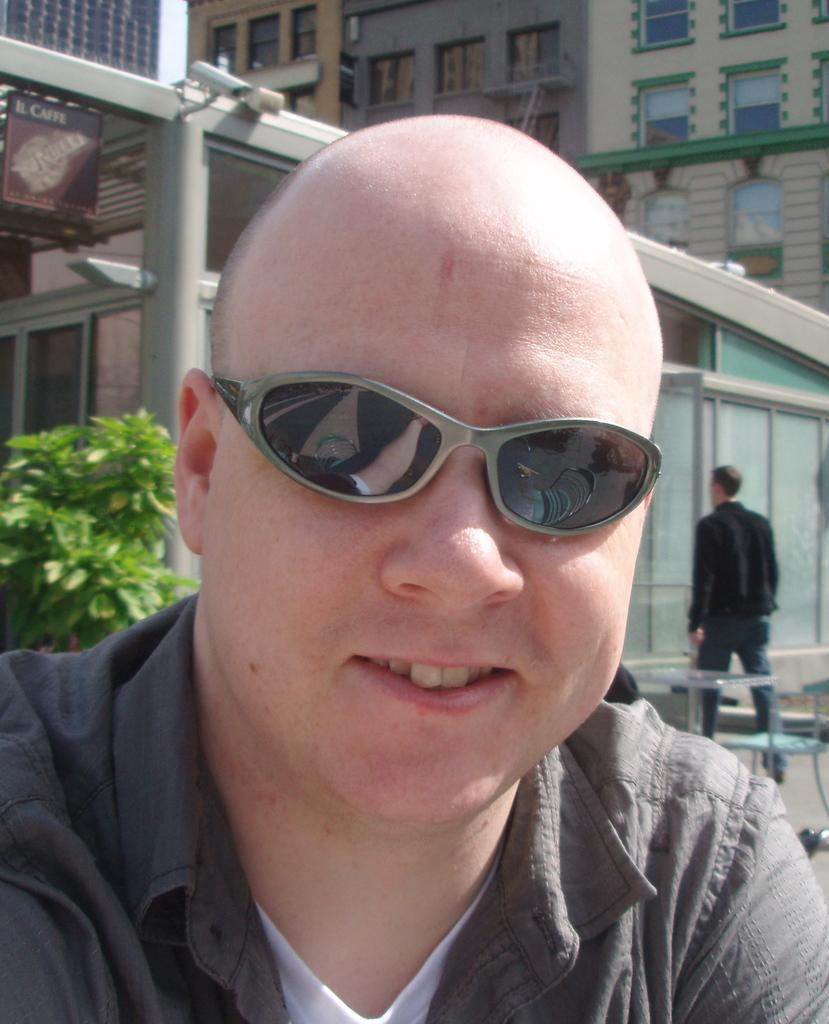How many people are visible in the image? There are people in the image, but the exact number cannot be determined from the provided facts. What type of furniture is present in the image? There are chairs and tables in the image. What architectural feature can be seen in the image? There are glass doors in the image. What device is used to capture the image? There is a camera in the image. What type of structures are visible in the background of the image? There are buildings with windows in the image. What type of decorations are present in the image? There are posters in the image. What type of pickle is being used as a prop in the image? There is no pickle present in the image. How many hands are visible in the image? The exact number of hands cannot be determined from the provided facts. 